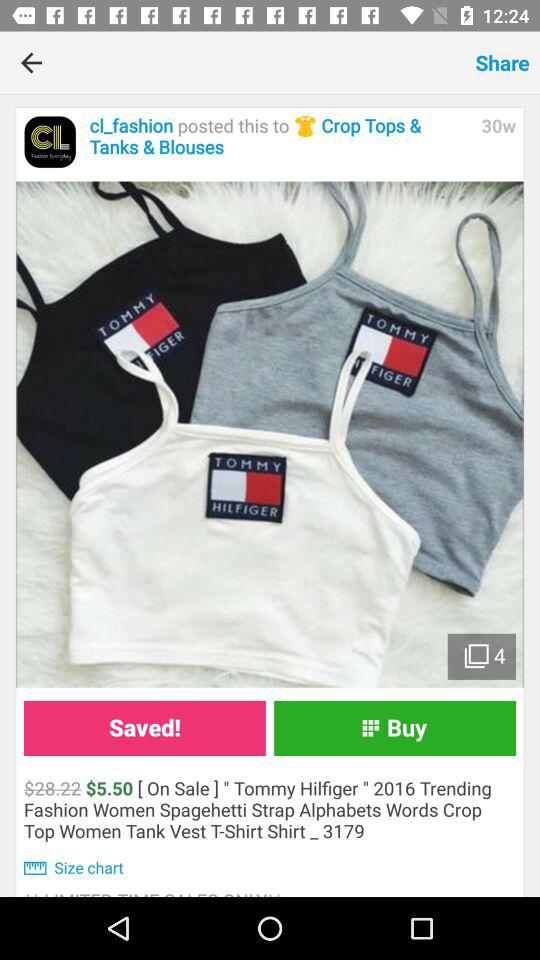How much is the sale price of the item?
Answer the question using a single word or phrase. $5.50 